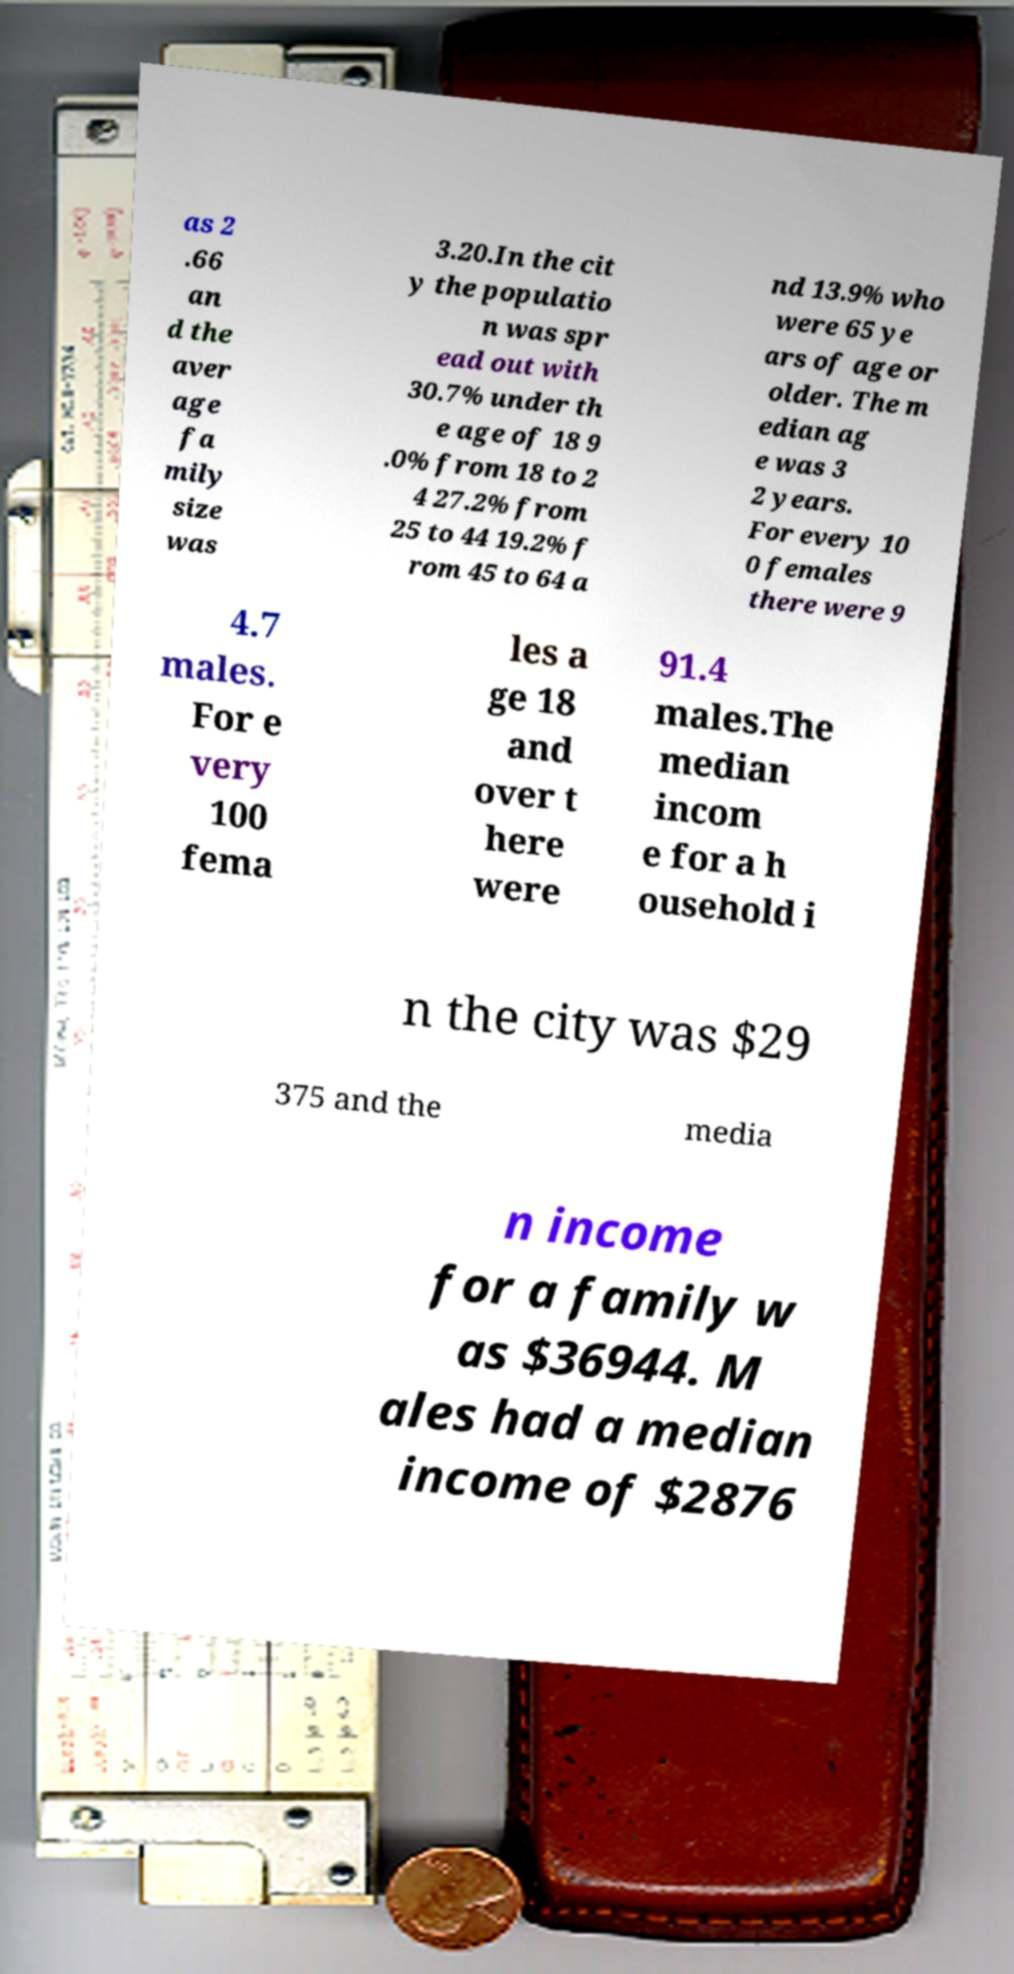Please read and relay the text visible in this image. What does it say? as 2 .66 an d the aver age fa mily size was 3.20.In the cit y the populatio n was spr ead out with 30.7% under th e age of 18 9 .0% from 18 to 2 4 27.2% from 25 to 44 19.2% f rom 45 to 64 a nd 13.9% who were 65 ye ars of age or older. The m edian ag e was 3 2 years. For every 10 0 females there were 9 4.7 males. For e very 100 fema les a ge 18 and over t here were 91.4 males.The median incom e for a h ousehold i n the city was $29 375 and the media n income for a family w as $36944. M ales had a median income of $2876 